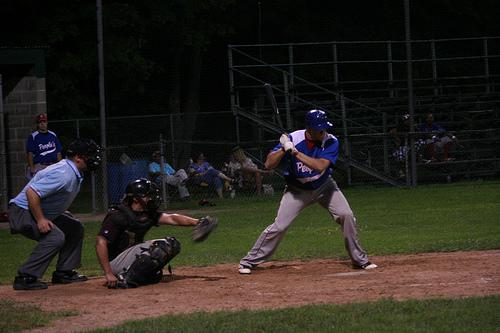Tell me what the main character in the image is wearing and the action they are taking. The primary subject is a batter in a blue helmet and jersey, holding a bat, ready to hit the ball in a baseball game. Comment on the overall atmosphere of the image. The image exudes excitement and anticipation as the batter, catcher, and umpire are all poised for action during a competitive, high-energy baseball game. Describe the image focusing on the clothing and equipment used by the subjects. A baseball player in a blue helmet and white-striped jersey, a catcher with a black leather glove, and an umpire in a blue shirt and face mask populate the scene. In one sentence, mention the key elements seen in this picture. A helmeted batter, catcher with mitt, and umpire adorn the baseball field, surrounded by a fence, green grass, and spectators on metal stands. Provide a brief description of the primary focus of the image. A baseball player wearing a shiny blue helmet and holding a bat is ready to hit the ball while the catcher and umpire wait. Write a short descriptive sentence about the scene in the image. In a lively baseball game, a helmeted batter prepares to swing as the catcher and umpire keenly observe. Give a concise summary of the image's main scene and elements. A tense baseball scene featuring a batter with a helmet, an attentive catcher, and an observing umpire on a grassy field with a fence, dirt, and stands. Express the main idea of the image in an assertive sentence. A focused batter dons a blue helmet and wields a bat while being closely watched by the observing catcher and umpire during an intense baseball game. Using vivid imagery, describe the overarching theme of the image. The tension mounts on the baseball field as the batter, donned in a blue helmet, stands ready to strike, with the watchful eyes of the umpire and catcher poised nearby. Mention three central characters of the image and their roles. The batter is holding the bat and wearing a helmet, the catcher is crouched down with a mitt, and the umpire is standing behind the catcher observing. 